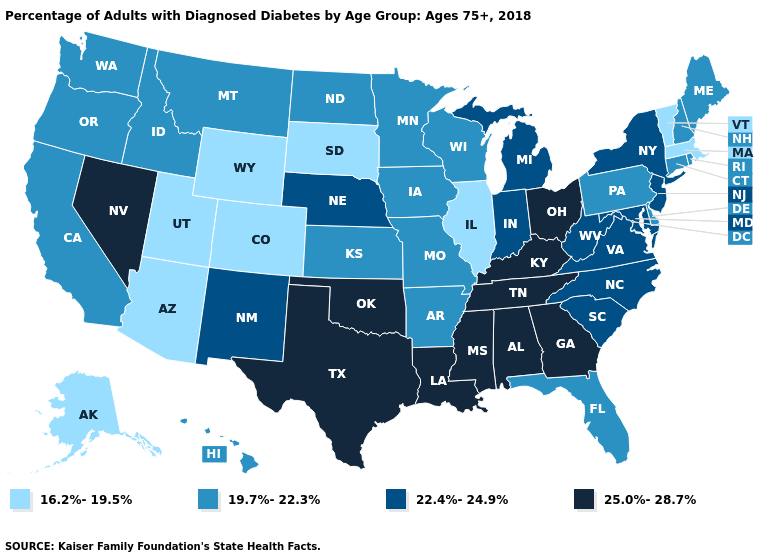Which states have the lowest value in the West?
Be succinct. Alaska, Arizona, Colorado, Utah, Wyoming. Does Delaware have the lowest value in the South?
Short answer required. Yes. Does the first symbol in the legend represent the smallest category?
Keep it brief. Yes. Which states hav the highest value in the West?
Keep it brief. Nevada. Name the states that have a value in the range 25.0%-28.7%?
Keep it brief. Alabama, Georgia, Kentucky, Louisiana, Mississippi, Nevada, Ohio, Oklahoma, Tennessee, Texas. What is the value of Louisiana?
Concise answer only. 25.0%-28.7%. Does Ohio have the lowest value in the MidWest?
Give a very brief answer. No. Does South Dakota have the lowest value in the MidWest?
Concise answer only. Yes. What is the value of Oregon?
Answer briefly. 19.7%-22.3%. Among the states that border Connecticut , which have the highest value?
Answer briefly. New York. How many symbols are there in the legend?
Concise answer only. 4. Name the states that have a value in the range 19.7%-22.3%?
Write a very short answer. Arkansas, California, Connecticut, Delaware, Florida, Hawaii, Idaho, Iowa, Kansas, Maine, Minnesota, Missouri, Montana, New Hampshire, North Dakota, Oregon, Pennsylvania, Rhode Island, Washington, Wisconsin. What is the highest value in the Northeast ?
Give a very brief answer. 22.4%-24.9%. Does Ohio have the highest value in the MidWest?
Short answer required. Yes. 